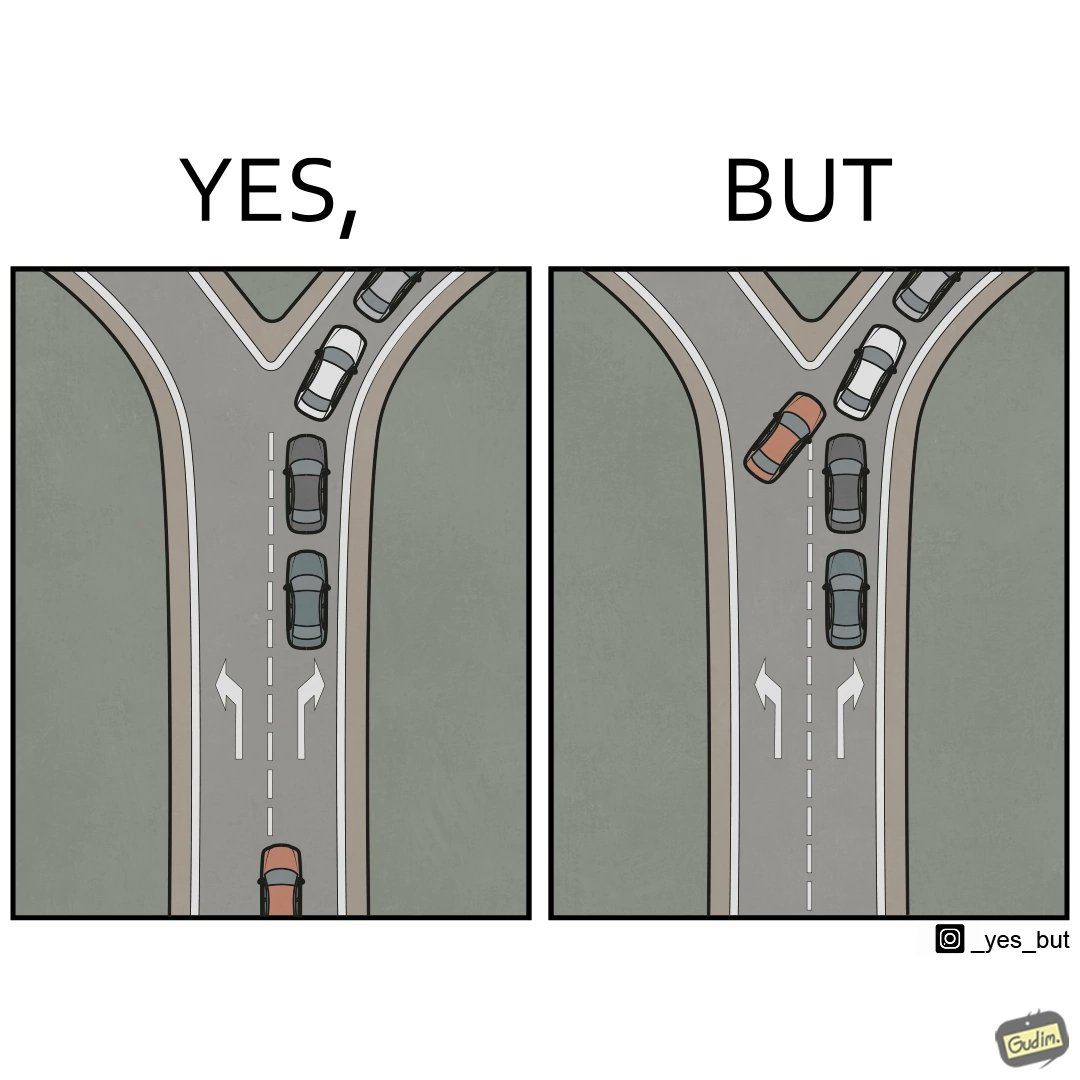Is there satirical content in this image? Yes, this image is satirical. 